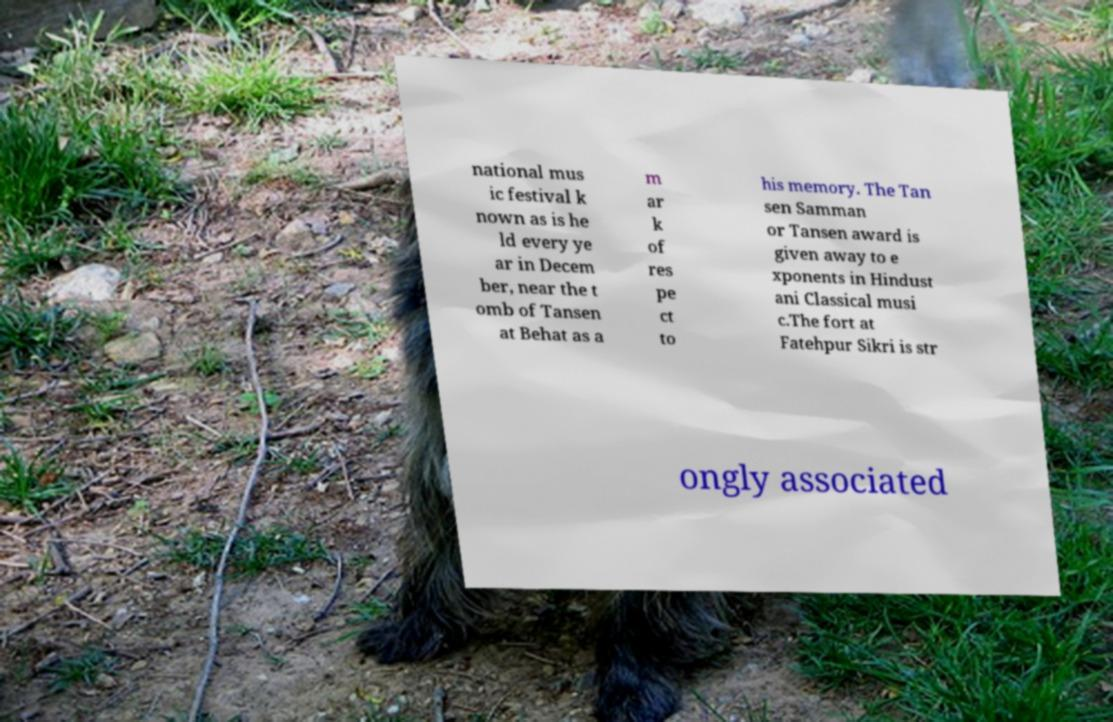Could you assist in decoding the text presented in this image and type it out clearly? national mus ic festival k nown as is he ld every ye ar in Decem ber, near the t omb of Tansen at Behat as a m ar k of res pe ct to his memory. The Tan sen Samman or Tansen award is given away to e xponents in Hindust ani Classical musi c.The fort at Fatehpur Sikri is str ongly associated 